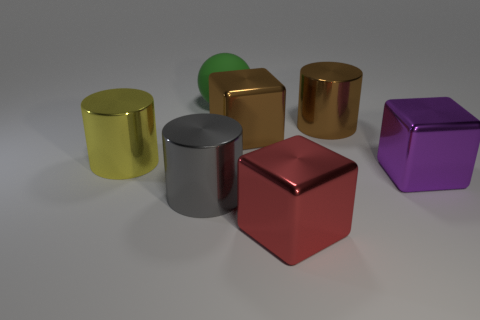Is there any other thing that has the same material as the big red thing?
Your answer should be compact. Yes. What shape is the purple metallic object that is the same size as the yellow metal thing?
Offer a very short reply. Cube. Is there a large metallic cylinder that has the same color as the ball?
Offer a terse response. No. Are there the same number of big matte balls that are right of the brown metal cylinder and yellow shiny spheres?
Your answer should be compact. Yes. There is a metal cube that is both to the left of the big purple cube and in front of the big yellow metal cylinder; what is its size?
Keep it short and to the point. Large. What number of big brown cylinders have the same material as the big yellow object?
Provide a succinct answer. 1. Is the number of large gray objects behind the gray object the same as the number of spheres that are in front of the brown cylinder?
Give a very brief answer. Yes. There is a matte thing; does it have the same shape as the brown shiny thing that is left of the red shiny thing?
Your answer should be compact. No. Is there any other thing that has the same shape as the red thing?
Offer a terse response. Yes. Are the green sphere and the large cylinder behind the large yellow metal thing made of the same material?
Make the answer very short. No. 